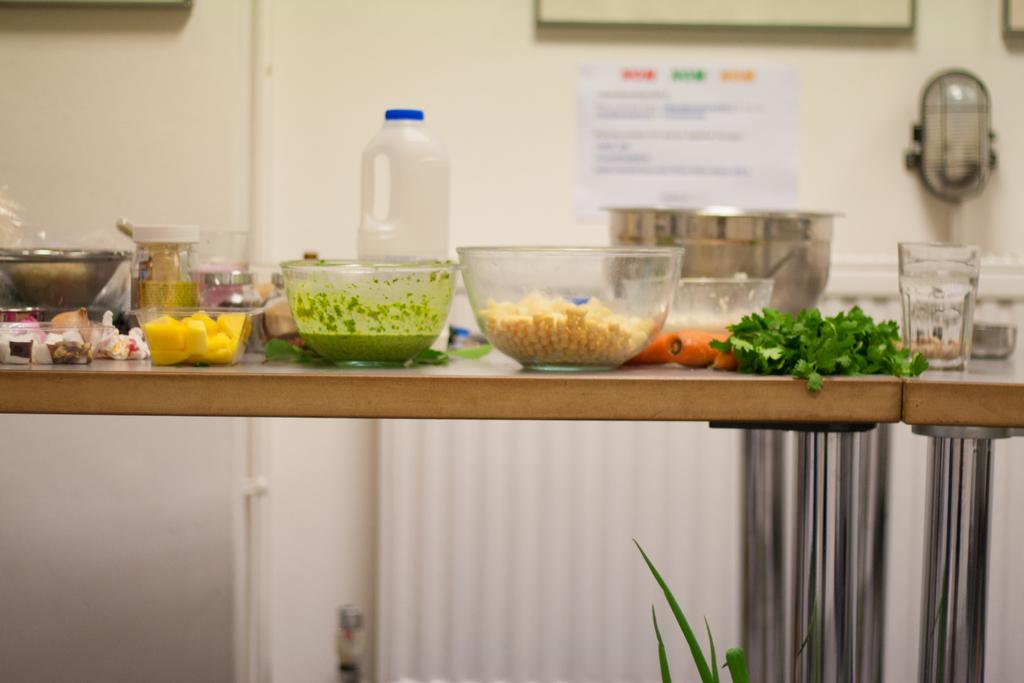What is the main piece of furniture in the image? There is a table in the image. What is placed on the table? There are bowls on the table, and there is food in the bowls. What else can be seen on the table? There are bottles and a glass on the table, as well as coriander. Can you describe the background of the image? The background of the image is blurred. What country is depicted in the image? There is no country depicted in the image; it is a close-up view of a table with various items on it. What effect does the coriander have on the food in the image? The image does not show any interaction between the coriander and the food, so it is not possible to determine any effect it might have. 